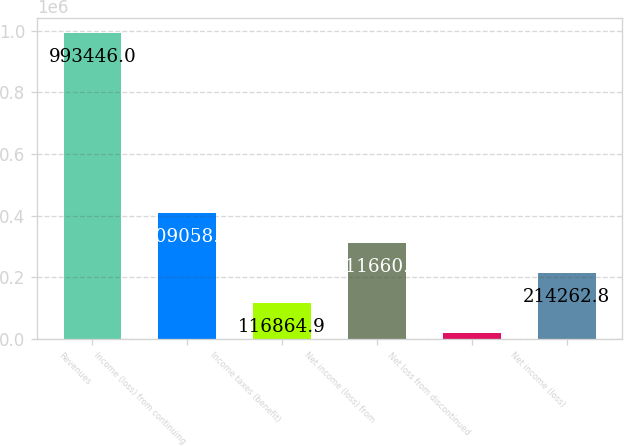Convert chart. <chart><loc_0><loc_0><loc_500><loc_500><bar_chart><fcel>Revenues<fcel>Income (loss) from continuing<fcel>Income taxes (benefit)<fcel>Net income (loss) from<fcel>Net loss from discontinued<fcel>Net income (loss)<nl><fcel>993446<fcel>409059<fcel>116865<fcel>311661<fcel>19467<fcel>214263<nl></chart> 